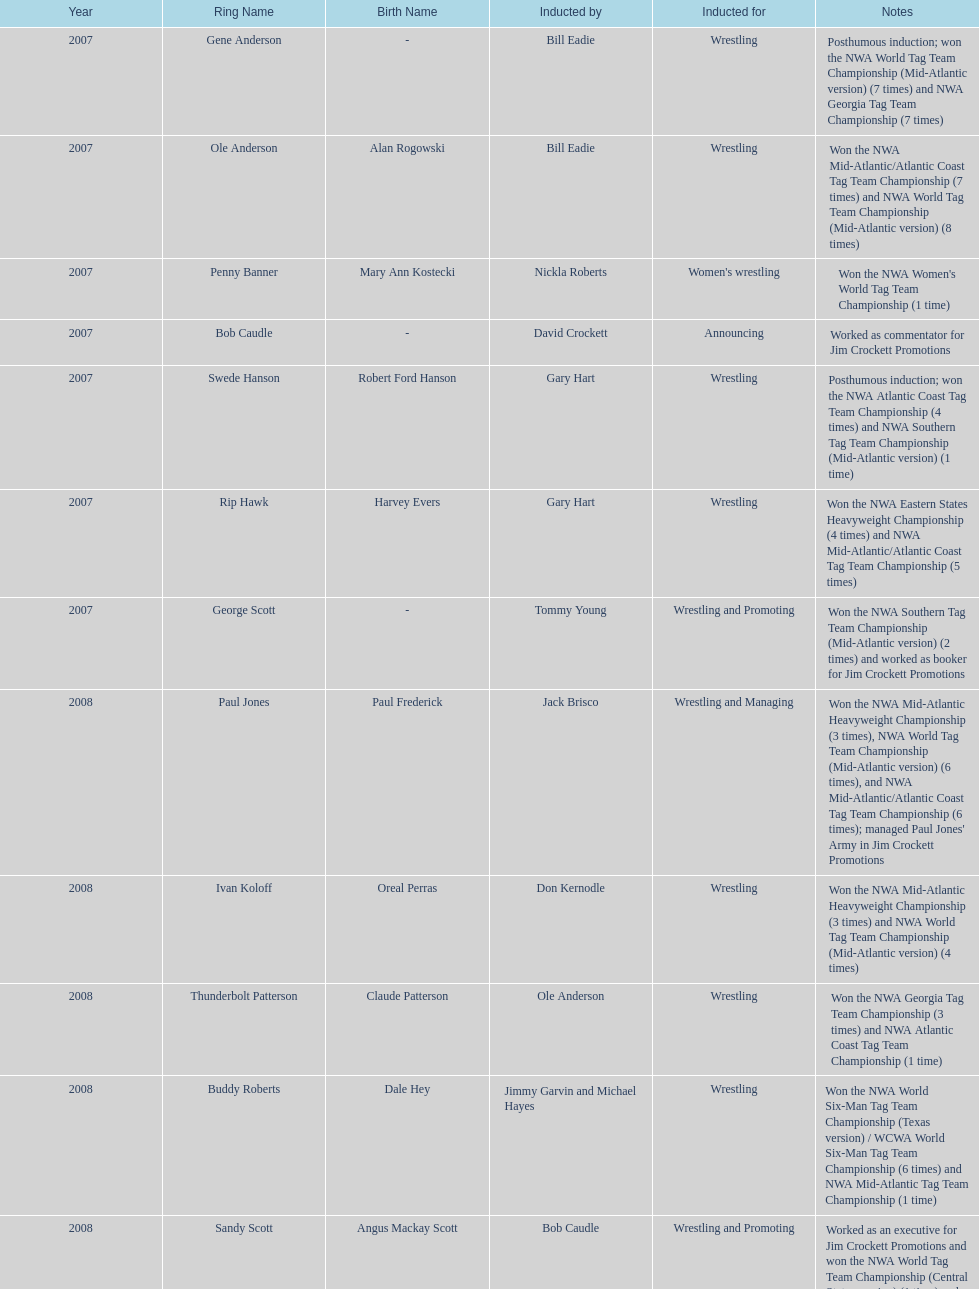Who's real name is dale hey, grizzly smith or buddy roberts? Buddy Roberts. 